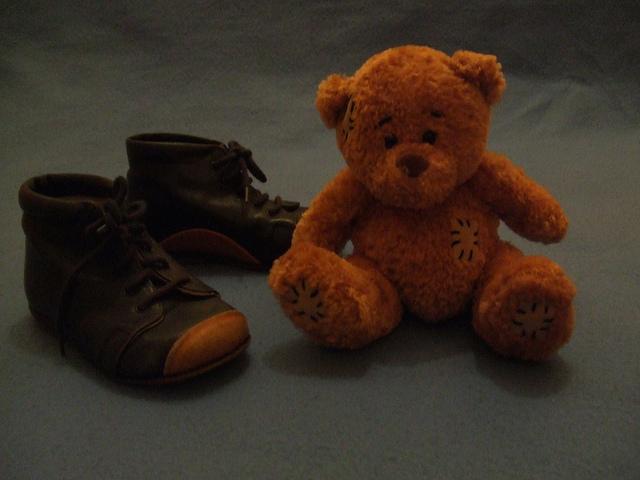Do teddy bears wear shoes?
Give a very brief answer. No. Is the teddy bear brown?
Write a very short answer. Yes. Are both shoes standing up?
Be succinct. Yes. Is the teddy bear bigger than the shoes?
Concise answer only. Yes. 